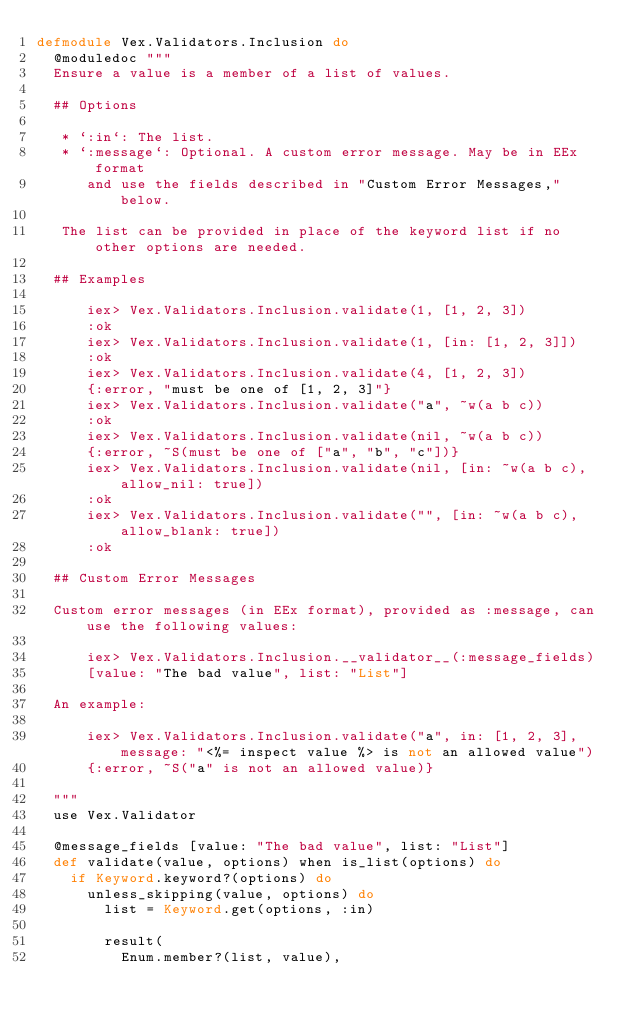Convert code to text. <code><loc_0><loc_0><loc_500><loc_500><_Elixir_>defmodule Vex.Validators.Inclusion do
  @moduledoc """
  Ensure a value is a member of a list of values.

  ## Options

   * `:in`: The list.
   * `:message`: Optional. A custom error message. May be in EEx format
      and use the fields described in "Custom Error Messages," below.

   The list can be provided in place of the keyword list if no other options are needed.

  ## Examples

      iex> Vex.Validators.Inclusion.validate(1, [1, 2, 3])
      :ok
      iex> Vex.Validators.Inclusion.validate(1, [in: [1, 2, 3]])
      :ok
      iex> Vex.Validators.Inclusion.validate(4, [1, 2, 3])
      {:error, "must be one of [1, 2, 3]"}
      iex> Vex.Validators.Inclusion.validate("a", ~w(a b c))
      :ok
      iex> Vex.Validators.Inclusion.validate(nil, ~w(a b c))
      {:error, ~S(must be one of ["a", "b", "c"])}
      iex> Vex.Validators.Inclusion.validate(nil, [in: ~w(a b c), allow_nil: true])
      :ok
      iex> Vex.Validators.Inclusion.validate("", [in: ~w(a b c), allow_blank: true])
      :ok

  ## Custom Error Messages

  Custom error messages (in EEx format), provided as :message, can use the following values:

      iex> Vex.Validators.Inclusion.__validator__(:message_fields)
      [value: "The bad value", list: "List"]

  An example:

      iex> Vex.Validators.Inclusion.validate("a", in: [1, 2, 3], message: "<%= inspect value %> is not an allowed value")
      {:error, ~S("a" is not an allowed value)}

  """
  use Vex.Validator

  @message_fields [value: "The bad value", list: "List"]
  def validate(value, options) when is_list(options) do
    if Keyword.keyword?(options) do
      unless_skipping(value, options) do
        list = Keyword.get(options, :in)

        result(
          Enum.member?(list, value),</code> 